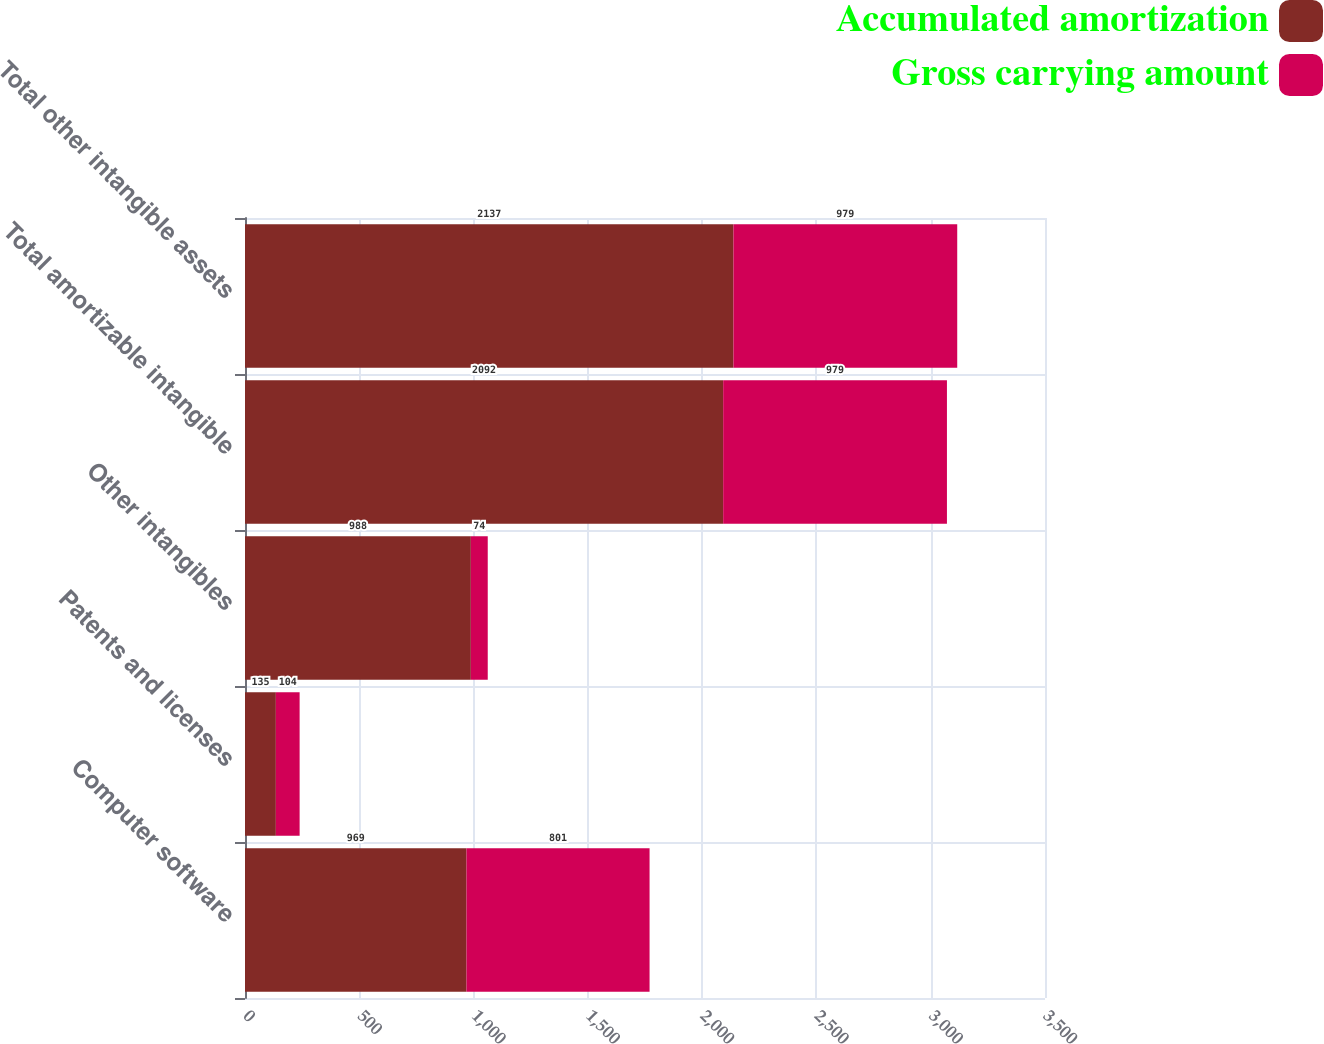Convert chart to OTSL. <chart><loc_0><loc_0><loc_500><loc_500><stacked_bar_chart><ecel><fcel>Computer software<fcel>Patents and licenses<fcel>Other intangibles<fcel>Total amortizable intangible<fcel>Total other intangible assets<nl><fcel>Accumulated amortization<fcel>969<fcel>135<fcel>988<fcel>2092<fcel>2137<nl><fcel>Gross carrying amount<fcel>801<fcel>104<fcel>74<fcel>979<fcel>979<nl></chart> 